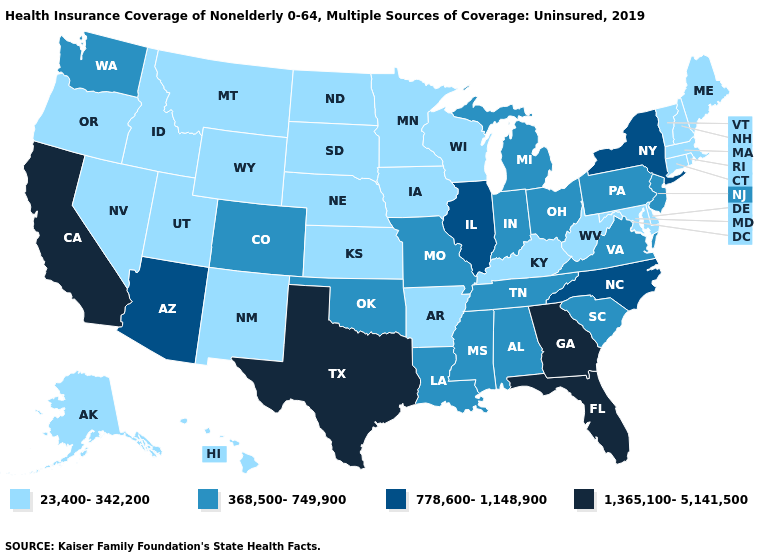Which states hav the highest value in the West?
Be succinct. California. Name the states that have a value in the range 778,600-1,148,900?
Be succinct. Arizona, Illinois, New York, North Carolina. Does Georgia have the lowest value in the USA?
Answer briefly. No. Does Ohio have a higher value than North Carolina?
Give a very brief answer. No. Name the states that have a value in the range 778,600-1,148,900?
Answer briefly. Arizona, Illinois, New York, North Carolina. What is the value of Hawaii?
Short answer required. 23,400-342,200. What is the value of Nebraska?
Quick response, please. 23,400-342,200. Name the states that have a value in the range 778,600-1,148,900?
Quick response, please. Arizona, Illinois, New York, North Carolina. Among the states that border Iowa , which have the lowest value?
Concise answer only. Minnesota, Nebraska, South Dakota, Wisconsin. Does California have the highest value in the USA?
Answer briefly. Yes. Name the states that have a value in the range 23,400-342,200?
Concise answer only. Alaska, Arkansas, Connecticut, Delaware, Hawaii, Idaho, Iowa, Kansas, Kentucky, Maine, Maryland, Massachusetts, Minnesota, Montana, Nebraska, Nevada, New Hampshire, New Mexico, North Dakota, Oregon, Rhode Island, South Dakota, Utah, Vermont, West Virginia, Wisconsin, Wyoming. Name the states that have a value in the range 23,400-342,200?
Write a very short answer. Alaska, Arkansas, Connecticut, Delaware, Hawaii, Idaho, Iowa, Kansas, Kentucky, Maine, Maryland, Massachusetts, Minnesota, Montana, Nebraska, Nevada, New Hampshire, New Mexico, North Dakota, Oregon, Rhode Island, South Dakota, Utah, Vermont, West Virginia, Wisconsin, Wyoming. What is the value of Arkansas?
Answer briefly. 23,400-342,200. 